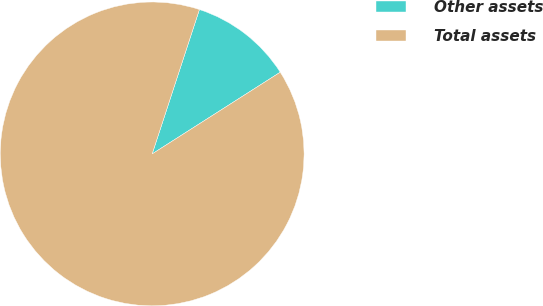<chart> <loc_0><loc_0><loc_500><loc_500><pie_chart><fcel>Other assets<fcel>Total assets<nl><fcel>10.93%<fcel>89.07%<nl></chart> 